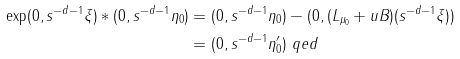Convert formula to latex. <formula><loc_0><loc_0><loc_500><loc_500>\exp ( 0 , s ^ { - d - 1 } \xi ) \ast ( 0 , s ^ { - d - 1 } \eta _ { 0 } ) & = ( 0 , s ^ { - d - 1 } \eta _ { 0 } ) - ( 0 , ( L _ { \mu _ { 0 } } + u B ) ( s ^ { - d - 1 } \xi ) ) \\ & = ( 0 , s ^ { - d - 1 } \eta _ { 0 } ^ { \prime } ) \ q e d</formula> 